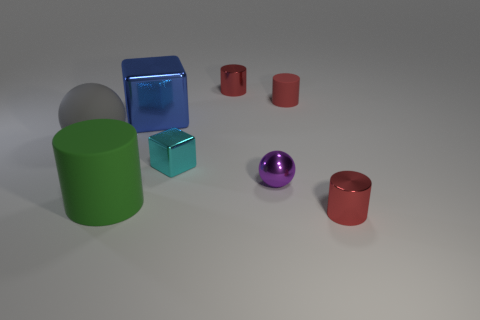How many red cylinders must be subtracted to get 2 red cylinders? 1 Subtract all green rubber cylinders. How many cylinders are left? 3 Subtract all cyan spheres. How many red cylinders are left? 3 Add 2 large spheres. How many objects exist? 10 Subtract all green cylinders. How many cylinders are left? 3 Subtract all balls. How many objects are left? 6 Subtract all brown cylinders. Subtract all red balls. How many cylinders are left? 4 Subtract all large green objects. Subtract all large cylinders. How many objects are left? 6 Add 6 cyan metallic objects. How many cyan metallic objects are left? 7 Add 1 big cylinders. How many big cylinders exist? 2 